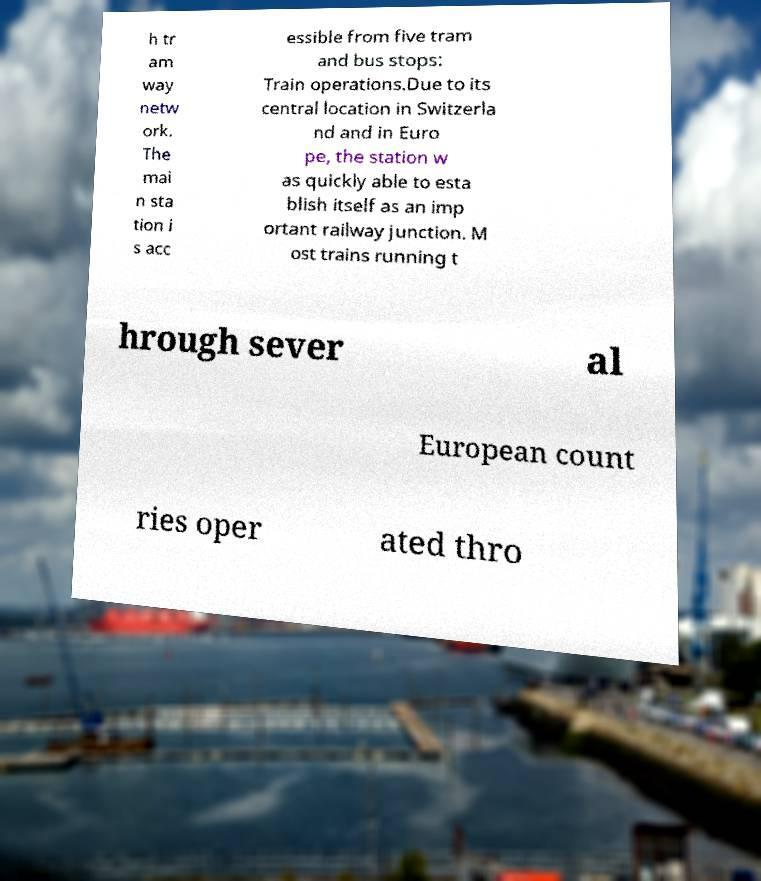Can you accurately transcribe the text from the provided image for me? h tr am way netw ork. The mai n sta tion i s acc essible from five tram and bus stops: Train operations.Due to its central location in Switzerla nd and in Euro pe, the station w as quickly able to esta blish itself as an imp ortant railway junction. M ost trains running t hrough sever al European count ries oper ated thro 